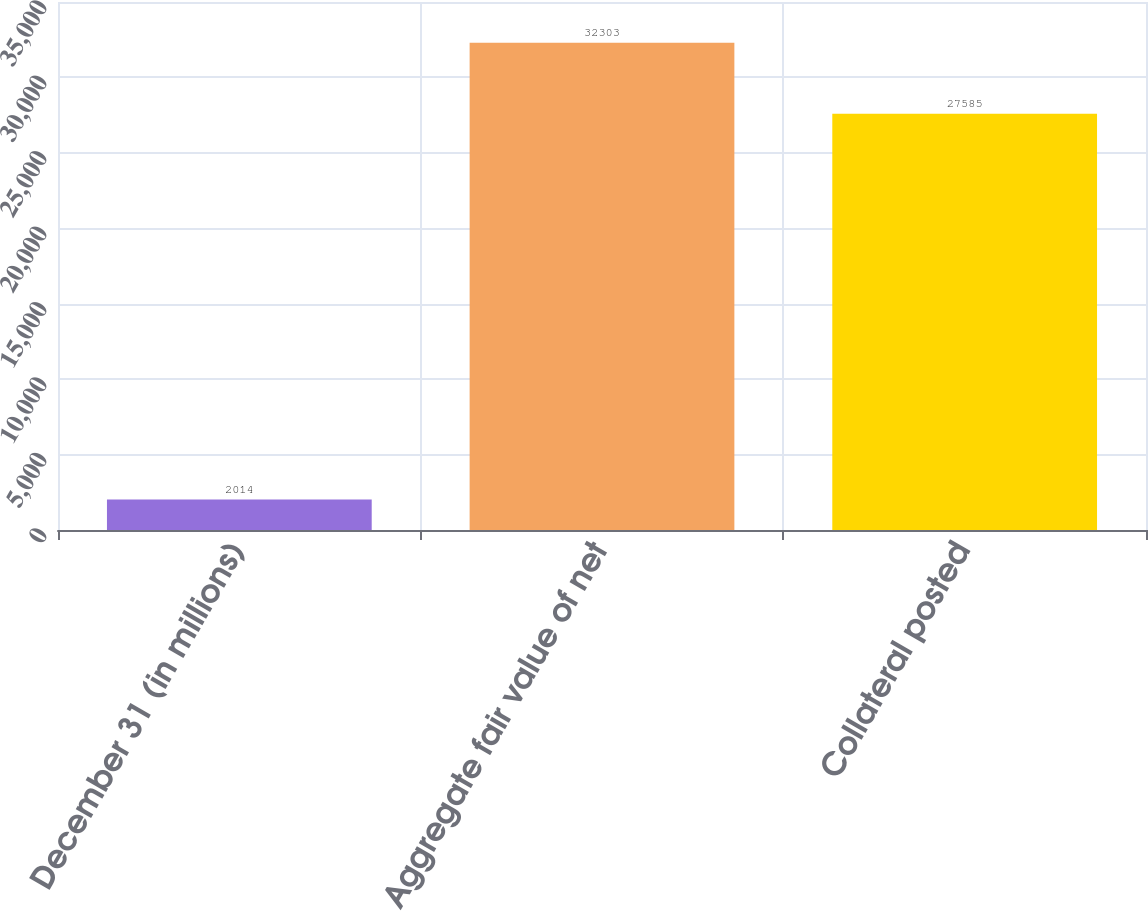<chart> <loc_0><loc_0><loc_500><loc_500><bar_chart><fcel>December 31 (in millions)<fcel>Aggregate fair value of net<fcel>Collateral posted<nl><fcel>2014<fcel>32303<fcel>27585<nl></chart> 